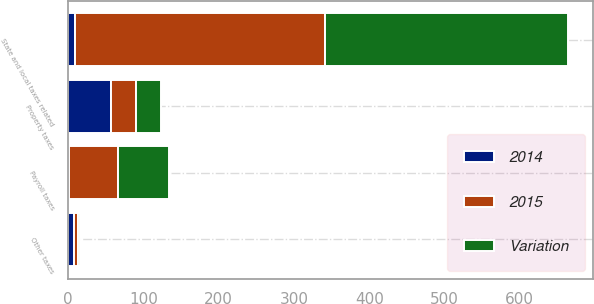<chart> <loc_0><loc_0><loc_500><loc_500><stacked_bar_chart><ecel><fcel>Property taxes<fcel>State and local taxes related<fcel>Payroll taxes<fcel>Other taxes<nl><fcel>Variation<fcel>33<fcel>323<fcel>67<fcel>3<nl><fcel>2015<fcel>33<fcel>332<fcel>65<fcel>5<nl><fcel>2014<fcel>57<fcel>9<fcel>2<fcel>8<nl></chart> 